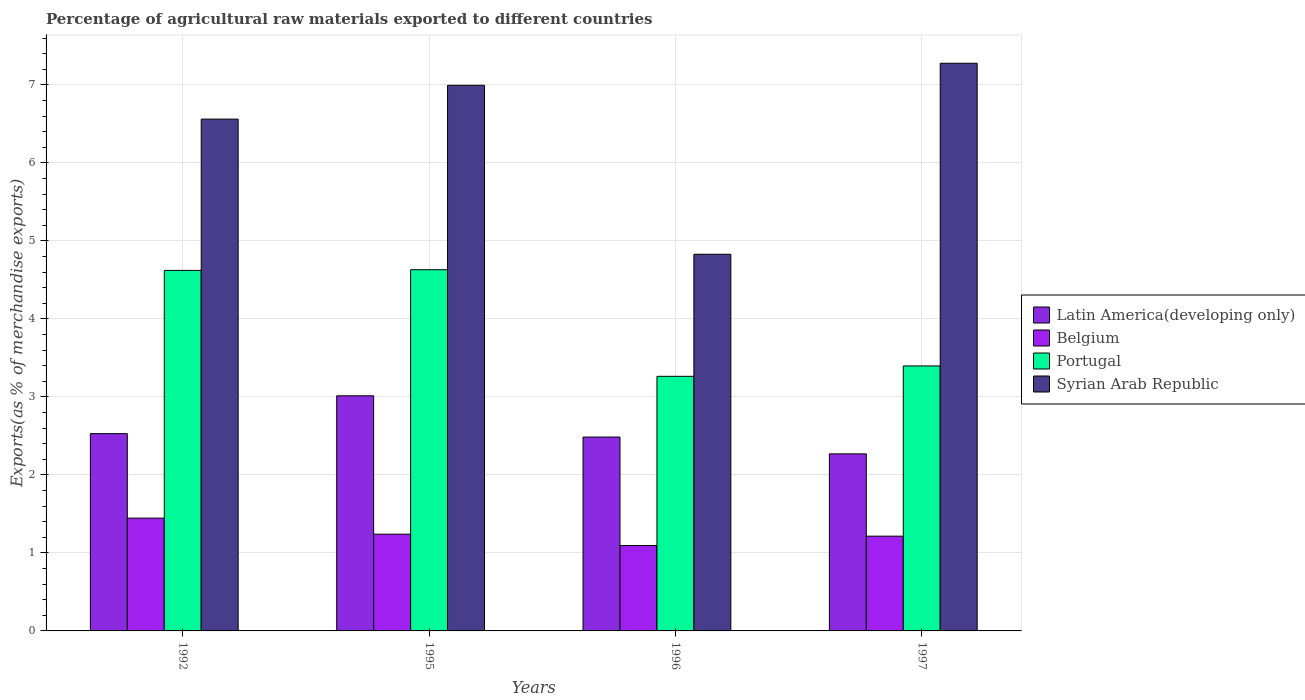How many different coloured bars are there?
Your answer should be very brief. 4. How many groups of bars are there?
Offer a very short reply. 4. Are the number of bars per tick equal to the number of legend labels?
Your answer should be compact. Yes. Are the number of bars on each tick of the X-axis equal?
Ensure brevity in your answer.  Yes. How many bars are there on the 3rd tick from the left?
Offer a terse response. 4. How many bars are there on the 3rd tick from the right?
Keep it short and to the point. 4. What is the label of the 2nd group of bars from the left?
Your answer should be very brief. 1995. What is the percentage of exports to different countries in Portugal in 1996?
Your answer should be compact. 3.26. Across all years, what is the maximum percentage of exports to different countries in Belgium?
Offer a very short reply. 1.45. Across all years, what is the minimum percentage of exports to different countries in Latin America(developing only)?
Your answer should be very brief. 2.27. What is the total percentage of exports to different countries in Syrian Arab Republic in the graph?
Offer a very short reply. 25.66. What is the difference between the percentage of exports to different countries in Latin America(developing only) in 1992 and that in 1995?
Keep it short and to the point. -0.48. What is the difference between the percentage of exports to different countries in Portugal in 1992 and the percentage of exports to different countries in Belgium in 1995?
Provide a short and direct response. 3.38. What is the average percentage of exports to different countries in Belgium per year?
Give a very brief answer. 1.25. In the year 1992, what is the difference between the percentage of exports to different countries in Latin America(developing only) and percentage of exports to different countries in Belgium?
Your answer should be compact. 1.08. What is the ratio of the percentage of exports to different countries in Portugal in 1992 to that in 1995?
Offer a terse response. 1. Is the percentage of exports to different countries in Portugal in 1992 less than that in 1997?
Your answer should be very brief. No. What is the difference between the highest and the second highest percentage of exports to different countries in Portugal?
Offer a very short reply. 0.01. What is the difference between the highest and the lowest percentage of exports to different countries in Portugal?
Ensure brevity in your answer.  1.37. In how many years, is the percentage of exports to different countries in Latin America(developing only) greater than the average percentage of exports to different countries in Latin America(developing only) taken over all years?
Make the answer very short. 1. Is the sum of the percentage of exports to different countries in Portugal in 1992 and 1996 greater than the maximum percentage of exports to different countries in Belgium across all years?
Offer a terse response. Yes. Is it the case that in every year, the sum of the percentage of exports to different countries in Portugal and percentage of exports to different countries in Belgium is greater than the sum of percentage of exports to different countries in Syrian Arab Republic and percentage of exports to different countries in Latin America(developing only)?
Make the answer very short. Yes. What does the 4th bar from the left in 1996 represents?
Keep it short and to the point. Syrian Arab Republic. Is it the case that in every year, the sum of the percentage of exports to different countries in Syrian Arab Republic and percentage of exports to different countries in Portugal is greater than the percentage of exports to different countries in Belgium?
Ensure brevity in your answer.  Yes. How many bars are there?
Give a very brief answer. 16. Are all the bars in the graph horizontal?
Make the answer very short. No. How many years are there in the graph?
Give a very brief answer. 4. Where does the legend appear in the graph?
Your answer should be very brief. Center right. How many legend labels are there?
Your answer should be compact. 4. What is the title of the graph?
Your response must be concise. Percentage of agricultural raw materials exported to different countries. What is the label or title of the Y-axis?
Give a very brief answer. Exports(as % of merchandise exports). What is the Exports(as % of merchandise exports) in Latin America(developing only) in 1992?
Your answer should be very brief. 2.53. What is the Exports(as % of merchandise exports) in Belgium in 1992?
Make the answer very short. 1.45. What is the Exports(as % of merchandise exports) of Portugal in 1992?
Keep it short and to the point. 4.62. What is the Exports(as % of merchandise exports) of Syrian Arab Republic in 1992?
Ensure brevity in your answer.  6.56. What is the Exports(as % of merchandise exports) of Latin America(developing only) in 1995?
Ensure brevity in your answer.  3.01. What is the Exports(as % of merchandise exports) of Belgium in 1995?
Offer a very short reply. 1.24. What is the Exports(as % of merchandise exports) in Portugal in 1995?
Make the answer very short. 4.63. What is the Exports(as % of merchandise exports) in Syrian Arab Republic in 1995?
Offer a terse response. 6.99. What is the Exports(as % of merchandise exports) of Latin America(developing only) in 1996?
Keep it short and to the point. 2.49. What is the Exports(as % of merchandise exports) in Belgium in 1996?
Offer a very short reply. 1.09. What is the Exports(as % of merchandise exports) of Portugal in 1996?
Your answer should be compact. 3.26. What is the Exports(as % of merchandise exports) of Syrian Arab Republic in 1996?
Make the answer very short. 4.83. What is the Exports(as % of merchandise exports) of Latin America(developing only) in 1997?
Provide a succinct answer. 2.27. What is the Exports(as % of merchandise exports) in Belgium in 1997?
Offer a very short reply. 1.21. What is the Exports(as % of merchandise exports) of Portugal in 1997?
Keep it short and to the point. 3.4. What is the Exports(as % of merchandise exports) in Syrian Arab Republic in 1997?
Ensure brevity in your answer.  7.28. Across all years, what is the maximum Exports(as % of merchandise exports) in Latin America(developing only)?
Your response must be concise. 3.01. Across all years, what is the maximum Exports(as % of merchandise exports) in Belgium?
Provide a short and direct response. 1.45. Across all years, what is the maximum Exports(as % of merchandise exports) of Portugal?
Keep it short and to the point. 4.63. Across all years, what is the maximum Exports(as % of merchandise exports) of Syrian Arab Republic?
Provide a short and direct response. 7.28. Across all years, what is the minimum Exports(as % of merchandise exports) of Latin America(developing only)?
Your answer should be compact. 2.27. Across all years, what is the minimum Exports(as % of merchandise exports) in Belgium?
Ensure brevity in your answer.  1.09. Across all years, what is the minimum Exports(as % of merchandise exports) of Portugal?
Provide a short and direct response. 3.26. Across all years, what is the minimum Exports(as % of merchandise exports) in Syrian Arab Republic?
Make the answer very short. 4.83. What is the total Exports(as % of merchandise exports) of Latin America(developing only) in the graph?
Give a very brief answer. 10.3. What is the total Exports(as % of merchandise exports) of Belgium in the graph?
Your answer should be compact. 5. What is the total Exports(as % of merchandise exports) of Portugal in the graph?
Make the answer very short. 15.91. What is the total Exports(as % of merchandise exports) in Syrian Arab Republic in the graph?
Offer a very short reply. 25.66. What is the difference between the Exports(as % of merchandise exports) of Latin America(developing only) in 1992 and that in 1995?
Your answer should be compact. -0.48. What is the difference between the Exports(as % of merchandise exports) of Belgium in 1992 and that in 1995?
Your answer should be very brief. 0.21. What is the difference between the Exports(as % of merchandise exports) of Portugal in 1992 and that in 1995?
Give a very brief answer. -0.01. What is the difference between the Exports(as % of merchandise exports) in Syrian Arab Republic in 1992 and that in 1995?
Provide a short and direct response. -0.43. What is the difference between the Exports(as % of merchandise exports) in Latin America(developing only) in 1992 and that in 1996?
Your response must be concise. 0.04. What is the difference between the Exports(as % of merchandise exports) of Belgium in 1992 and that in 1996?
Make the answer very short. 0.35. What is the difference between the Exports(as % of merchandise exports) in Portugal in 1992 and that in 1996?
Offer a very short reply. 1.36. What is the difference between the Exports(as % of merchandise exports) in Syrian Arab Republic in 1992 and that in 1996?
Your response must be concise. 1.73. What is the difference between the Exports(as % of merchandise exports) in Latin America(developing only) in 1992 and that in 1997?
Offer a very short reply. 0.26. What is the difference between the Exports(as % of merchandise exports) of Belgium in 1992 and that in 1997?
Offer a very short reply. 0.23. What is the difference between the Exports(as % of merchandise exports) of Portugal in 1992 and that in 1997?
Provide a succinct answer. 1.22. What is the difference between the Exports(as % of merchandise exports) of Syrian Arab Republic in 1992 and that in 1997?
Your answer should be very brief. -0.72. What is the difference between the Exports(as % of merchandise exports) of Latin America(developing only) in 1995 and that in 1996?
Your response must be concise. 0.53. What is the difference between the Exports(as % of merchandise exports) in Belgium in 1995 and that in 1996?
Provide a succinct answer. 0.15. What is the difference between the Exports(as % of merchandise exports) in Portugal in 1995 and that in 1996?
Give a very brief answer. 1.37. What is the difference between the Exports(as % of merchandise exports) in Syrian Arab Republic in 1995 and that in 1996?
Your answer should be compact. 2.17. What is the difference between the Exports(as % of merchandise exports) of Latin America(developing only) in 1995 and that in 1997?
Your response must be concise. 0.74. What is the difference between the Exports(as % of merchandise exports) in Belgium in 1995 and that in 1997?
Provide a short and direct response. 0.03. What is the difference between the Exports(as % of merchandise exports) in Portugal in 1995 and that in 1997?
Give a very brief answer. 1.23. What is the difference between the Exports(as % of merchandise exports) in Syrian Arab Republic in 1995 and that in 1997?
Give a very brief answer. -0.28. What is the difference between the Exports(as % of merchandise exports) in Latin America(developing only) in 1996 and that in 1997?
Your answer should be very brief. 0.22. What is the difference between the Exports(as % of merchandise exports) in Belgium in 1996 and that in 1997?
Provide a succinct answer. -0.12. What is the difference between the Exports(as % of merchandise exports) in Portugal in 1996 and that in 1997?
Your response must be concise. -0.13. What is the difference between the Exports(as % of merchandise exports) in Syrian Arab Republic in 1996 and that in 1997?
Offer a very short reply. -2.45. What is the difference between the Exports(as % of merchandise exports) of Latin America(developing only) in 1992 and the Exports(as % of merchandise exports) of Belgium in 1995?
Provide a short and direct response. 1.29. What is the difference between the Exports(as % of merchandise exports) in Latin America(developing only) in 1992 and the Exports(as % of merchandise exports) in Portugal in 1995?
Offer a terse response. -2.1. What is the difference between the Exports(as % of merchandise exports) in Latin America(developing only) in 1992 and the Exports(as % of merchandise exports) in Syrian Arab Republic in 1995?
Your response must be concise. -4.47. What is the difference between the Exports(as % of merchandise exports) of Belgium in 1992 and the Exports(as % of merchandise exports) of Portugal in 1995?
Provide a succinct answer. -3.18. What is the difference between the Exports(as % of merchandise exports) of Belgium in 1992 and the Exports(as % of merchandise exports) of Syrian Arab Republic in 1995?
Your answer should be very brief. -5.55. What is the difference between the Exports(as % of merchandise exports) in Portugal in 1992 and the Exports(as % of merchandise exports) in Syrian Arab Republic in 1995?
Offer a very short reply. -2.37. What is the difference between the Exports(as % of merchandise exports) in Latin America(developing only) in 1992 and the Exports(as % of merchandise exports) in Belgium in 1996?
Ensure brevity in your answer.  1.43. What is the difference between the Exports(as % of merchandise exports) of Latin America(developing only) in 1992 and the Exports(as % of merchandise exports) of Portugal in 1996?
Offer a terse response. -0.73. What is the difference between the Exports(as % of merchandise exports) in Latin America(developing only) in 1992 and the Exports(as % of merchandise exports) in Syrian Arab Republic in 1996?
Offer a very short reply. -2.3. What is the difference between the Exports(as % of merchandise exports) in Belgium in 1992 and the Exports(as % of merchandise exports) in Portugal in 1996?
Make the answer very short. -1.82. What is the difference between the Exports(as % of merchandise exports) in Belgium in 1992 and the Exports(as % of merchandise exports) in Syrian Arab Republic in 1996?
Keep it short and to the point. -3.38. What is the difference between the Exports(as % of merchandise exports) of Portugal in 1992 and the Exports(as % of merchandise exports) of Syrian Arab Republic in 1996?
Keep it short and to the point. -0.21. What is the difference between the Exports(as % of merchandise exports) of Latin America(developing only) in 1992 and the Exports(as % of merchandise exports) of Belgium in 1997?
Your answer should be compact. 1.31. What is the difference between the Exports(as % of merchandise exports) of Latin America(developing only) in 1992 and the Exports(as % of merchandise exports) of Portugal in 1997?
Your response must be concise. -0.87. What is the difference between the Exports(as % of merchandise exports) in Latin America(developing only) in 1992 and the Exports(as % of merchandise exports) in Syrian Arab Republic in 1997?
Keep it short and to the point. -4.75. What is the difference between the Exports(as % of merchandise exports) of Belgium in 1992 and the Exports(as % of merchandise exports) of Portugal in 1997?
Your response must be concise. -1.95. What is the difference between the Exports(as % of merchandise exports) of Belgium in 1992 and the Exports(as % of merchandise exports) of Syrian Arab Republic in 1997?
Keep it short and to the point. -5.83. What is the difference between the Exports(as % of merchandise exports) of Portugal in 1992 and the Exports(as % of merchandise exports) of Syrian Arab Republic in 1997?
Your response must be concise. -2.66. What is the difference between the Exports(as % of merchandise exports) of Latin America(developing only) in 1995 and the Exports(as % of merchandise exports) of Belgium in 1996?
Ensure brevity in your answer.  1.92. What is the difference between the Exports(as % of merchandise exports) in Latin America(developing only) in 1995 and the Exports(as % of merchandise exports) in Portugal in 1996?
Your answer should be compact. -0.25. What is the difference between the Exports(as % of merchandise exports) in Latin America(developing only) in 1995 and the Exports(as % of merchandise exports) in Syrian Arab Republic in 1996?
Offer a terse response. -1.81. What is the difference between the Exports(as % of merchandise exports) in Belgium in 1995 and the Exports(as % of merchandise exports) in Portugal in 1996?
Your answer should be compact. -2.02. What is the difference between the Exports(as % of merchandise exports) in Belgium in 1995 and the Exports(as % of merchandise exports) in Syrian Arab Republic in 1996?
Offer a very short reply. -3.59. What is the difference between the Exports(as % of merchandise exports) of Portugal in 1995 and the Exports(as % of merchandise exports) of Syrian Arab Republic in 1996?
Provide a short and direct response. -0.2. What is the difference between the Exports(as % of merchandise exports) of Latin America(developing only) in 1995 and the Exports(as % of merchandise exports) of Belgium in 1997?
Offer a terse response. 1.8. What is the difference between the Exports(as % of merchandise exports) in Latin America(developing only) in 1995 and the Exports(as % of merchandise exports) in Portugal in 1997?
Offer a very short reply. -0.38. What is the difference between the Exports(as % of merchandise exports) of Latin America(developing only) in 1995 and the Exports(as % of merchandise exports) of Syrian Arab Republic in 1997?
Keep it short and to the point. -4.26. What is the difference between the Exports(as % of merchandise exports) in Belgium in 1995 and the Exports(as % of merchandise exports) in Portugal in 1997?
Provide a short and direct response. -2.16. What is the difference between the Exports(as % of merchandise exports) of Belgium in 1995 and the Exports(as % of merchandise exports) of Syrian Arab Republic in 1997?
Your response must be concise. -6.04. What is the difference between the Exports(as % of merchandise exports) of Portugal in 1995 and the Exports(as % of merchandise exports) of Syrian Arab Republic in 1997?
Offer a very short reply. -2.65. What is the difference between the Exports(as % of merchandise exports) in Latin America(developing only) in 1996 and the Exports(as % of merchandise exports) in Belgium in 1997?
Provide a short and direct response. 1.27. What is the difference between the Exports(as % of merchandise exports) of Latin America(developing only) in 1996 and the Exports(as % of merchandise exports) of Portugal in 1997?
Your response must be concise. -0.91. What is the difference between the Exports(as % of merchandise exports) of Latin America(developing only) in 1996 and the Exports(as % of merchandise exports) of Syrian Arab Republic in 1997?
Provide a succinct answer. -4.79. What is the difference between the Exports(as % of merchandise exports) in Belgium in 1996 and the Exports(as % of merchandise exports) in Portugal in 1997?
Give a very brief answer. -2.3. What is the difference between the Exports(as % of merchandise exports) in Belgium in 1996 and the Exports(as % of merchandise exports) in Syrian Arab Republic in 1997?
Your answer should be very brief. -6.18. What is the difference between the Exports(as % of merchandise exports) in Portugal in 1996 and the Exports(as % of merchandise exports) in Syrian Arab Republic in 1997?
Give a very brief answer. -4.01. What is the average Exports(as % of merchandise exports) in Latin America(developing only) per year?
Give a very brief answer. 2.57. What is the average Exports(as % of merchandise exports) of Belgium per year?
Keep it short and to the point. 1.25. What is the average Exports(as % of merchandise exports) in Portugal per year?
Your answer should be compact. 3.98. What is the average Exports(as % of merchandise exports) in Syrian Arab Republic per year?
Provide a short and direct response. 6.42. In the year 1992, what is the difference between the Exports(as % of merchandise exports) of Latin America(developing only) and Exports(as % of merchandise exports) of Belgium?
Make the answer very short. 1.08. In the year 1992, what is the difference between the Exports(as % of merchandise exports) in Latin America(developing only) and Exports(as % of merchandise exports) in Portugal?
Offer a terse response. -2.09. In the year 1992, what is the difference between the Exports(as % of merchandise exports) in Latin America(developing only) and Exports(as % of merchandise exports) in Syrian Arab Republic?
Your answer should be very brief. -4.03. In the year 1992, what is the difference between the Exports(as % of merchandise exports) in Belgium and Exports(as % of merchandise exports) in Portugal?
Offer a terse response. -3.18. In the year 1992, what is the difference between the Exports(as % of merchandise exports) of Belgium and Exports(as % of merchandise exports) of Syrian Arab Republic?
Offer a terse response. -5.11. In the year 1992, what is the difference between the Exports(as % of merchandise exports) of Portugal and Exports(as % of merchandise exports) of Syrian Arab Republic?
Provide a succinct answer. -1.94. In the year 1995, what is the difference between the Exports(as % of merchandise exports) in Latin America(developing only) and Exports(as % of merchandise exports) in Belgium?
Offer a terse response. 1.77. In the year 1995, what is the difference between the Exports(as % of merchandise exports) in Latin America(developing only) and Exports(as % of merchandise exports) in Portugal?
Your answer should be compact. -1.62. In the year 1995, what is the difference between the Exports(as % of merchandise exports) in Latin America(developing only) and Exports(as % of merchandise exports) in Syrian Arab Republic?
Your answer should be compact. -3.98. In the year 1995, what is the difference between the Exports(as % of merchandise exports) in Belgium and Exports(as % of merchandise exports) in Portugal?
Provide a succinct answer. -3.39. In the year 1995, what is the difference between the Exports(as % of merchandise exports) of Belgium and Exports(as % of merchandise exports) of Syrian Arab Republic?
Ensure brevity in your answer.  -5.75. In the year 1995, what is the difference between the Exports(as % of merchandise exports) of Portugal and Exports(as % of merchandise exports) of Syrian Arab Republic?
Provide a short and direct response. -2.36. In the year 1996, what is the difference between the Exports(as % of merchandise exports) of Latin America(developing only) and Exports(as % of merchandise exports) of Belgium?
Your response must be concise. 1.39. In the year 1996, what is the difference between the Exports(as % of merchandise exports) of Latin America(developing only) and Exports(as % of merchandise exports) of Portugal?
Offer a terse response. -0.78. In the year 1996, what is the difference between the Exports(as % of merchandise exports) in Latin America(developing only) and Exports(as % of merchandise exports) in Syrian Arab Republic?
Keep it short and to the point. -2.34. In the year 1996, what is the difference between the Exports(as % of merchandise exports) in Belgium and Exports(as % of merchandise exports) in Portugal?
Offer a terse response. -2.17. In the year 1996, what is the difference between the Exports(as % of merchandise exports) of Belgium and Exports(as % of merchandise exports) of Syrian Arab Republic?
Ensure brevity in your answer.  -3.73. In the year 1996, what is the difference between the Exports(as % of merchandise exports) of Portugal and Exports(as % of merchandise exports) of Syrian Arab Republic?
Your response must be concise. -1.56. In the year 1997, what is the difference between the Exports(as % of merchandise exports) of Latin America(developing only) and Exports(as % of merchandise exports) of Belgium?
Your answer should be very brief. 1.05. In the year 1997, what is the difference between the Exports(as % of merchandise exports) in Latin America(developing only) and Exports(as % of merchandise exports) in Portugal?
Offer a very short reply. -1.13. In the year 1997, what is the difference between the Exports(as % of merchandise exports) in Latin America(developing only) and Exports(as % of merchandise exports) in Syrian Arab Republic?
Keep it short and to the point. -5.01. In the year 1997, what is the difference between the Exports(as % of merchandise exports) of Belgium and Exports(as % of merchandise exports) of Portugal?
Make the answer very short. -2.18. In the year 1997, what is the difference between the Exports(as % of merchandise exports) of Belgium and Exports(as % of merchandise exports) of Syrian Arab Republic?
Offer a very short reply. -6.06. In the year 1997, what is the difference between the Exports(as % of merchandise exports) in Portugal and Exports(as % of merchandise exports) in Syrian Arab Republic?
Make the answer very short. -3.88. What is the ratio of the Exports(as % of merchandise exports) in Latin America(developing only) in 1992 to that in 1995?
Ensure brevity in your answer.  0.84. What is the ratio of the Exports(as % of merchandise exports) in Belgium in 1992 to that in 1995?
Keep it short and to the point. 1.17. What is the ratio of the Exports(as % of merchandise exports) in Syrian Arab Republic in 1992 to that in 1995?
Your response must be concise. 0.94. What is the ratio of the Exports(as % of merchandise exports) in Latin America(developing only) in 1992 to that in 1996?
Your response must be concise. 1.02. What is the ratio of the Exports(as % of merchandise exports) of Belgium in 1992 to that in 1996?
Offer a very short reply. 1.32. What is the ratio of the Exports(as % of merchandise exports) in Portugal in 1992 to that in 1996?
Ensure brevity in your answer.  1.42. What is the ratio of the Exports(as % of merchandise exports) of Syrian Arab Republic in 1992 to that in 1996?
Give a very brief answer. 1.36. What is the ratio of the Exports(as % of merchandise exports) in Latin America(developing only) in 1992 to that in 1997?
Keep it short and to the point. 1.11. What is the ratio of the Exports(as % of merchandise exports) in Belgium in 1992 to that in 1997?
Offer a very short reply. 1.19. What is the ratio of the Exports(as % of merchandise exports) of Portugal in 1992 to that in 1997?
Offer a very short reply. 1.36. What is the ratio of the Exports(as % of merchandise exports) in Syrian Arab Republic in 1992 to that in 1997?
Ensure brevity in your answer.  0.9. What is the ratio of the Exports(as % of merchandise exports) in Latin America(developing only) in 1995 to that in 1996?
Your answer should be very brief. 1.21. What is the ratio of the Exports(as % of merchandise exports) in Belgium in 1995 to that in 1996?
Your response must be concise. 1.13. What is the ratio of the Exports(as % of merchandise exports) in Portugal in 1995 to that in 1996?
Your answer should be compact. 1.42. What is the ratio of the Exports(as % of merchandise exports) in Syrian Arab Republic in 1995 to that in 1996?
Offer a very short reply. 1.45. What is the ratio of the Exports(as % of merchandise exports) in Latin America(developing only) in 1995 to that in 1997?
Offer a terse response. 1.33. What is the ratio of the Exports(as % of merchandise exports) in Belgium in 1995 to that in 1997?
Make the answer very short. 1.02. What is the ratio of the Exports(as % of merchandise exports) of Portugal in 1995 to that in 1997?
Your answer should be compact. 1.36. What is the ratio of the Exports(as % of merchandise exports) in Syrian Arab Republic in 1995 to that in 1997?
Your answer should be compact. 0.96. What is the ratio of the Exports(as % of merchandise exports) in Latin America(developing only) in 1996 to that in 1997?
Provide a short and direct response. 1.09. What is the ratio of the Exports(as % of merchandise exports) of Belgium in 1996 to that in 1997?
Your response must be concise. 0.9. What is the ratio of the Exports(as % of merchandise exports) in Portugal in 1996 to that in 1997?
Give a very brief answer. 0.96. What is the ratio of the Exports(as % of merchandise exports) in Syrian Arab Republic in 1996 to that in 1997?
Offer a terse response. 0.66. What is the difference between the highest and the second highest Exports(as % of merchandise exports) of Latin America(developing only)?
Make the answer very short. 0.48. What is the difference between the highest and the second highest Exports(as % of merchandise exports) in Belgium?
Make the answer very short. 0.21. What is the difference between the highest and the second highest Exports(as % of merchandise exports) in Portugal?
Provide a succinct answer. 0.01. What is the difference between the highest and the second highest Exports(as % of merchandise exports) in Syrian Arab Republic?
Your answer should be compact. 0.28. What is the difference between the highest and the lowest Exports(as % of merchandise exports) of Latin America(developing only)?
Your response must be concise. 0.74. What is the difference between the highest and the lowest Exports(as % of merchandise exports) in Belgium?
Provide a short and direct response. 0.35. What is the difference between the highest and the lowest Exports(as % of merchandise exports) of Portugal?
Provide a succinct answer. 1.37. What is the difference between the highest and the lowest Exports(as % of merchandise exports) in Syrian Arab Republic?
Keep it short and to the point. 2.45. 